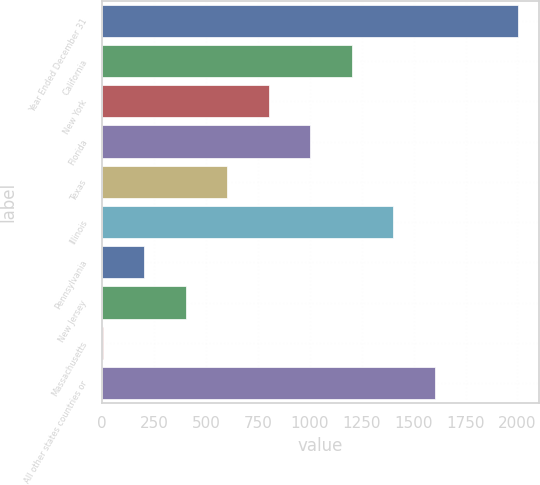Convert chart to OTSL. <chart><loc_0><loc_0><loc_500><loc_500><bar_chart><fcel>Year Ended December 31<fcel>California<fcel>New York<fcel>Florida<fcel>Texas<fcel>Illinois<fcel>Pennsylvania<fcel>New Jersey<fcel>Massachusetts<fcel>All other states countries or<nl><fcel>2003<fcel>1203.04<fcel>803.06<fcel>1003.05<fcel>603.07<fcel>1403.03<fcel>203.09<fcel>403.08<fcel>3.1<fcel>1603.02<nl></chart> 